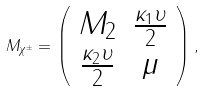Convert formula to latex. <formula><loc_0><loc_0><loc_500><loc_500>M _ { \chi ^ { \pm } } = \left ( \begin{array} { c c } M _ { 2 } & \frac { \kappa _ { 1 } \upsilon } { 2 } \\ \frac { \kappa _ { 2 } \upsilon } { 2 } & \mu \end{array} \right ) ,</formula> 